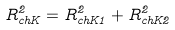<formula> <loc_0><loc_0><loc_500><loc_500>R _ { c h K } ^ { 2 } = R _ { c h K 1 } ^ { 2 } + R _ { c h K 2 } ^ { 2 }</formula> 